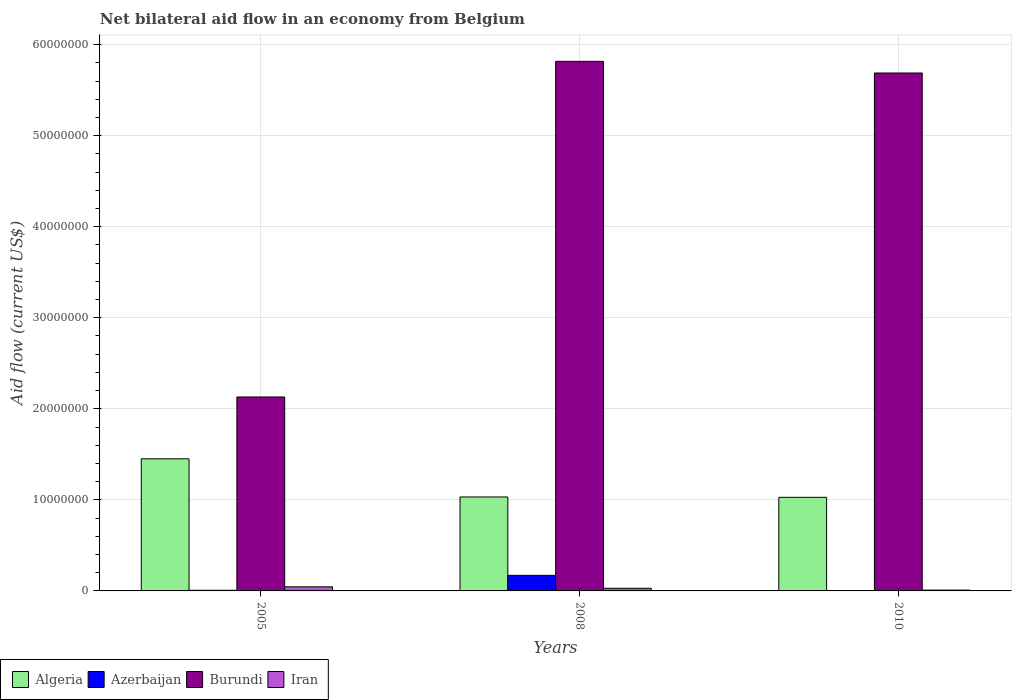How many different coloured bars are there?
Your answer should be compact. 4. Are the number of bars on each tick of the X-axis equal?
Ensure brevity in your answer.  Yes. In how many cases, is the number of bars for a given year not equal to the number of legend labels?
Make the answer very short. 0. Across all years, what is the maximum net bilateral aid flow in Burundi?
Make the answer very short. 5.82e+07. Across all years, what is the minimum net bilateral aid flow in Algeria?
Ensure brevity in your answer.  1.03e+07. In which year was the net bilateral aid flow in Iran maximum?
Make the answer very short. 2005. In which year was the net bilateral aid flow in Azerbaijan minimum?
Your response must be concise. 2010. What is the total net bilateral aid flow in Azerbaijan in the graph?
Provide a succinct answer. 1.79e+06. What is the difference between the net bilateral aid flow in Algeria in 2005 and that in 2008?
Ensure brevity in your answer.  4.19e+06. What is the difference between the net bilateral aid flow in Iran in 2008 and the net bilateral aid flow in Algeria in 2010?
Provide a short and direct response. -9.99e+06. What is the average net bilateral aid flow in Azerbaijan per year?
Ensure brevity in your answer.  5.97e+05. In the year 2008, what is the difference between the net bilateral aid flow in Iran and net bilateral aid flow in Burundi?
Your answer should be very brief. -5.79e+07. What is the ratio of the net bilateral aid flow in Burundi in 2005 to that in 2008?
Give a very brief answer. 0.37. Is the net bilateral aid flow in Iran in 2005 less than that in 2010?
Your answer should be very brief. No. What is the difference between the highest and the second highest net bilateral aid flow in Algeria?
Offer a very short reply. 4.19e+06. What is the difference between the highest and the lowest net bilateral aid flow in Iran?
Your response must be concise. 3.60e+05. In how many years, is the net bilateral aid flow in Azerbaijan greater than the average net bilateral aid flow in Azerbaijan taken over all years?
Your answer should be compact. 1. What does the 1st bar from the left in 2008 represents?
Give a very brief answer. Algeria. What does the 2nd bar from the right in 2005 represents?
Make the answer very short. Burundi. How many bars are there?
Give a very brief answer. 12. How many years are there in the graph?
Give a very brief answer. 3. What is the difference between two consecutive major ticks on the Y-axis?
Provide a succinct answer. 1.00e+07. Does the graph contain grids?
Your answer should be very brief. Yes. Where does the legend appear in the graph?
Your answer should be compact. Bottom left. How are the legend labels stacked?
Offer a very short reply. Horizontal. What is the title of the graph?
Keep it short and to the point. Net bilateral aid flow in an economy from Belgium. What is the label or title of the X-axis?
Your response must be concise. Years. What is the label or title of the Y-axis?
Keep it short and to the point. Aid flow (current US$). What is the Aid flow (current US$) in Algeria in 2005?
Keep it short and to the point. 1.45e+07. What is the Aid flow (current US$) of Azerbaijan in 2005?
Make the answer very short. 7.00e+04. What is the Aid flow (current US$) in Burundi in 2005?
Your answer should be compact. 2.13e+07. What is the Aid flow (current US$) of Algeria in 2008?
Your answer should be very brief. 1.03e+07. What is the Aid flow (current US$) in Azerbaijan in 2008?
Provide a short and direct response. 1.71e+06. What is the Aid flow (current US$) in Burundi in 2008?
Give a very brief answer. 5.82e+07. What is the Aid flow (current US$) in Iran in 2008?
Provide a succinct answer. 2.90e+05. What is the Aid flow (current US$) in Algeria in 2010?
Your response must be concise. 1.03e+07. What is the Aid flow (current US$) in Azerbaijan in 2010?
Make the answer very short. 10000. What is the Aid flow (current US$) in Burundi in 2010?
Keep it short and to the point. 5.69e+07. What is the Aid flow (current US$) of Iran in 2010?
Your response must be concise. 9.00e+04. Across all years, what is the maximum Aid flow (current US$) in Algeria?
Provide a short and direct response. 1.45e+07. Across all years, what is the maximum Aid flow (current US$) in Azerbaijan?
Your answer should be compact. 1.71e+06. Across all years, what is the maximum Aid flow (current US$) of Burundi?
Offer a very short reply. 5.82e+07. Across all years, what is the maximum Aid flow (current US$) in Iran?
Your response must be concise. 4.50e+05. Across all years, what is the minimum Aid flow (current US$) in Algeria?
Your response must be concise. 1.03e+07. Across all years, what is the minimum Aid flow (current US$) in Azerbaijan?
Offer a terse response. 10000. Across all years, what is the minimum Aid flow (current US$) of Burundi?
Provide a succinct answer. 2.13e+07. Across all years, what is the minimum Aid flow (current US$) in Iran?
Make the answer very short. 9.00e+04. What is the total Aid flow (current US$) in Algeria in the graph?
Offer a terse response. 3.51e+07. What is the total Aid flow (current US$) of Azerbaijan in the graph?
Your answer should be compact. 1.79e+06. What is the total Aid flow (current US$) in Burundi in the graph?
Offer a very short reply. 1.36e+08. What is the total Aid flow (current US$) of Iran in the graph?
Your response must be concise. 8.30e+05. What is the difference between the Aid flow (current US$) in Algeria in 2005 and that in 2008?
Make the answer very short. 4.19e+06. What is the difference between the Aid flow (current US$) in Azerbaijan in 2005 and that in 2008?
Offer a terse response. -1.64e+06. What is the difference between the Aid flow (current US$) in Burundi in 2005 and that in 2008?
Give a very brief answer. -3.69e+07. What is the difference between the Aid flow (current US$) of Iran in 2005 and that in 2008?
Your answer should be compact. 1.60e+05. What is the difference between the Aid flow (current US$) in Algeria in 2005 and that in 2010?
Make the answer very short. 4.23e+06. What is the difference between the Aid flow (current US$) of Burundi in 2005 and that in 2010?
Your answer should be compact. -3.56e+07. What is the difference between the Aid flow (current US$) in Algeria in 2008 and that in 2010?
Provide a succinct answer. 4.00e+04. What is the difference between the Aid flow (current US$) of Azerbaijan in 2008 and that in 2010?
Your response must be concise. 1.70e+06. What is the difference between the Aid flow (current US$) in Burundi in 2008 and that in 2010?
Provide a short and direct response. 1.28e+06. What is the difference between the Aid flow (current US$) in Algeria in 2005 and the Aid flow (current US$) in Azerbaijan in 2008?
Give a very brief answer. 1.28e+07. What is the difference between the Aid flow (current US$) of Algeria in 2005 and the Aid flow (current US$) of Burundi in 2008?
Offer a very short reply. -4.36e+07. What is the difference between the Aid flow (current US$) of Algeria in 2005 and the Aid flow (current US$) of Iran in 2008?
Offer a terse response. 1.42e+07. What is the difference between the Aid flow (current US$) of Azerbaijan in 2005 and the Aid flow (current US$) of Burundi in 2008?
Ensure brevity in your answer.  -5.81e+07. What is the difference between the Aid flow (current US$) in Burundi in 2005 and the Aid flow (current US$) in Iran in 2008?
Your response must be concise. 2.10e+07. What is the difference between the Aid flow (current US$) in Algeria in 2005 and the Aid flow (current US$) in Azerbaijan in 2010?
Your answer should be very brief. 1.45e+07. What is the difference between the Aid flow (current US$) in Algeria in 2005 and the Aid flow (current US$) in Burundi in 2010?
Offer a terse response. -4.24e+07. What is the difference between the Aid flow (current US$) in Algeria in 2005 and the Aid flow (current US$) in Iran in 2010?
Ensure brevity in your answer.  1.44e+07. What is the difference between the Aid flow (current US$) in Azerbaijan in 2005 and the Aid flow (current US$) in Burundi in 2010?
Your answer should be very brief. -5.68e+07. What is the difference between the Aid flow (current US$) of Azerbaijan in 2005 and the Aid flow (current US$) of Iran in 2010?
Provide a short and direct response. -2.00e+04. What is the difference between the Aid flow (current US$) of Burundi in 2005 and the Aid flow (current US$) of Iran in 2010?
Keep it short and to the point. 2.12e+07. What is the difference between the Aid flow (current US$) in Algeria in 2008 and the Aid flow (current US$) in Azerbaijan in 2010?
Offer a terse response. 1.03e+07. What is the difference between the Aid flow (current US$) of Algeria in 2008 and the Aid flow (current US$) of Burundi in 2010?
Give a very brief answer. -4.66e+07. What is the difference between the Aid flow (current US$) of Algeria in 2008 and the Aid flow (current US$) of Iran in 2010?
Your answer should be very brief. 1.02e+07. What is the difference between the Aid flow (current US$) of Azerbaijan in 2008 and the Aid flow (current US$) of Burundi in 2010?
Your answer should be very brief. -5.52e+07. What is the difference between the Aid flow (current US$) of Azerbaijan in 2008 and the Aid flow (current US$) of Iran in 2010?
Your response must be concise. 1.62e+06. What is the difference between the Aid flow (current US$) in Burundi in 2008 and the Aid flow (current US$) in Iran in 2010?
Make the answer very short. 5.81e+07. What is the average Aid flow (current US$) of Algeria per year?
Your answer should be compact. 1.17e+07. What is the average Aid flow (current US$) in Azerbaijan per year?
Offer a terse response. 5.97e+05. What is the average Aid flow (current US$) in Burundi per year?
Your response must be concise. 4.54e+07. What is the average Aid flow (current US$) of Iran per year?
Offer a very short reply. 2.77e+05. In the year 2005, what is the difference between the Aid flow (current US$) in Algeria and Aid flow (current US$) in Azerbaijan?
Your answer should be very brief. 1.44e+07. In the year 2005, what is the difference between the Aid flow (current US$) in Algeria and Aid flow (current US$) in Burundi?
Your answer should be very brief. -6.79e+06. In the year 2005, what is the difference between the Aid flow (current US$) in Algeria and Aid flow (current US$) in Iran?
Keep it short and to the point. 1.41e+07. In the year 2005, what is the difference between the Aid flow (current US$) of Azerbaijan and Aid flow (current US$) of Burundi?
Your answer should be compact. -2.12e+07. In the year 2005, what is the difference between the Aid flow (current US$) of Azerbaijan and Aid flow (current US$) of Iran?
Your answer should be very brief. -3.80e+05. In the year 2005, what is the difference between the Aid flow (current US$) of Burundi and Aid flow (current US$) of Iran?
Provide a succinct answer. 2.08e+07. In the year 2008, what is the difference between the Aid flow (current US$) in Algeria and Aid flow (current US$) in Azerbaijan?
Give a very brief answer. 8.61e+06. In the year 2008, what is the difference between the Aid flow (current US$) of Algeria and Aid flow (current US$) of Burundi?
Make the answer very short. -4.78e+07. In the year 2008, what is the difference between the Aid flow (current US$) in Algeria and Aid flow (current US$) in Iran?
Offer a terse response. 1.00e+07. In the year 2008, what is the difference between the Aid flow (current US$) in Azerbaijan and Aid flow (current US$) in Burundi?
Your answer should be compact. -5.64e+07. In the year 2008, what is the difference between the Aid flow (current US$) in Azerbaijan and Aid flow (current US$) in Iran?
Provide a short and direct response. 1.42e+06. In the year 2008, what is the difference between the Aid flow (current US$) in Burundi and Aid flow (current US$) in Iran?
Offer a terse response. 5.79e+07. In the year 2010, what is the difference between the Aid flow (current US$) in Algeria and Aid flow (current US$) in Azerbaijan?
Make the answer very short. 1.03e+07. In the year 2010, what is the difference between the Aid flow (current US$) of Algeria and Aid flow (current US$) of Burundi?
Provide a succinct answer. -4.66e+07. In the year 2010, what is the difference between the Aid flow (current US$) in Algeria and Aid flow (current US$) in Iran?
Give a very brief answer. 1.02e+07. In the year 2010, what is the difference between the Aid flow (current US$) in Azerbaijan and Aid flow (current US$) in Burundi?
Your answer should be very brief. -5.69e+07. In the year 2010, what is the difference between the Aid flow (current US$) in Azerbaijan and Aid flow (current US$) in Iran?
Offer a terse response. -8.00e+04. In the year 2010, what is the difference between the Aid flow (current US$) of Burundi and Aid flow (current US$) of Iran?
Provide a short and direct response. 5.68e+07. What is the ratio of the Aid flow (current US$) of Algeria in 2005 to that in 2008?
Offer a terse response. 1.41. What is the ratio of the Aid flow (current US$) of Azerbaijan in 2005 to that in 2008?
Give a very brief answer. 0.04. What is the ratio of the Aid flow (current US$) in Burundi in 2005 to that in 2008?
Provide a succinct answer. 0.37. What is the ratio of the Aid flow (current US$) in Iran in 2005 to that in 2008?
Your answer should be compact. 1.55. What is the ratio of the Aid flow (current US$) of Algeria in 2005 to that in 2010?
Give a very brief answer. 1.41. What is the ratio of the Aid flow (current US$) of Burundi in 2005 to that in 2010?
Your answer should be very brief. 0.37. What is the ratio of the Aid flow (current US$) in Iran in 2005 to that in 2010?
Keep it short and to the point. 5. What is the ratio of the Aid flow (current US$) in Algeria in 2008 to that in 2010?
Offer a terse response. 1. What is the ratio of the Aid flow (current US$) of Azerbaijan in 2008 to that in 2010?
Your response must be concise. 171. What is the ratio of the Aid flow (current US$) of Burundi in 2008 to that in 2010?
Your answer should be compact. 1.02. What is the ratio of the Aid flow (current US$) in Iran in 2008 to that in 2010?
Your answer should be very brief. 3.22. What is the difference between the highest and the second highest Aid flow (current US$) in Algeria?
Your response must be concise. 4.19e+06. What is the difference between the highest and the second highest Aid flow (current US$) of Azerbaijan?
Give a very brief answer. 1.64e+06. What is the difference between the highest and the second highest Aid flow (current US$) of Burundi?
Make the answer very short. 1.28e+06. What is the difference between the highest and the lowest Aid flow (current US$) in Algeria?
Offer a very short reply. 4.23e+06. What is the difference between the highest and the lowest Aid flow (current US$) of Azerbaijan?
Offer a very short reply. 1.70e+06. What is the difference between the highest and the lowest Aid flow (current US$) in Burundi?
Offer a very short reply. 3.69e+07. 